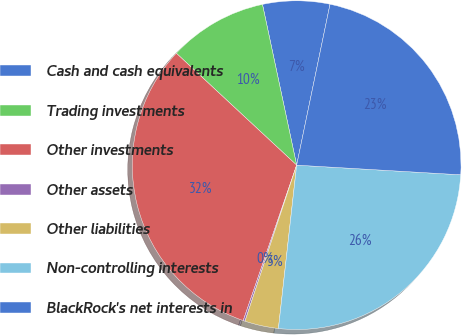Convert chart to OTSL. <chart><loc_0><loc_0><loc_500><loc_500><pie_chart><fcel>Cash and cash equivalents<fcel>Trading investments<fcel>Other investments<fcel>Other assets<fcel>Other liabilities<fcel>Non-controlling interests<fcel>BlackRock's net interests in<nl><fcel>6.59%<fcel>9.74%<fcel>31.65%<fcel>0.18%<fcel>3.32%<fcel>25.83%<fcel>22.68%<nl></chart> 